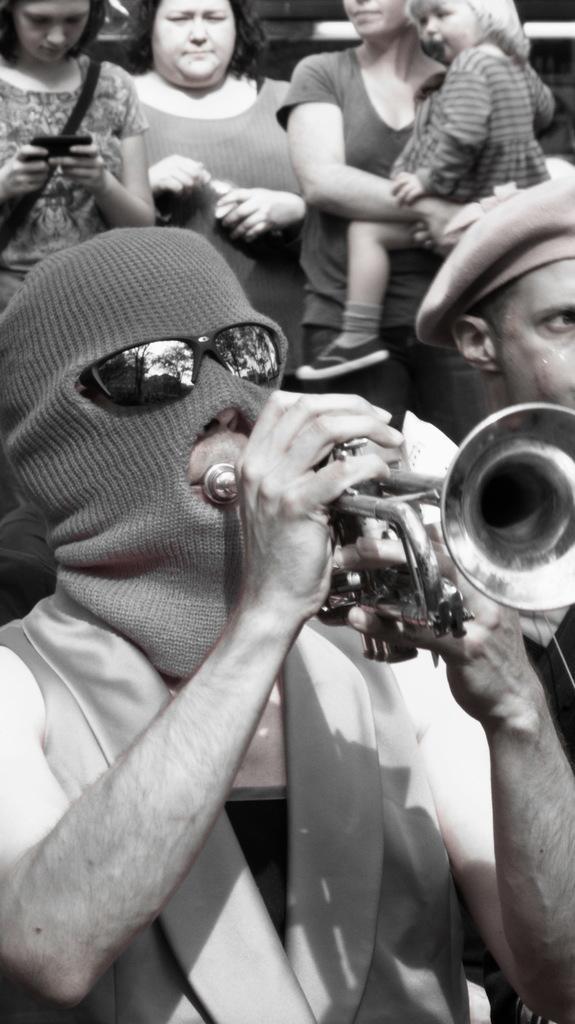In one or two sentences, can you explain what this image depicts? This picture is in black and white. The man in front of the picture wearing goggles is holding a trumpet in his hand. He is playing the trumpet. Behind him, we see people standing. On the left side, we see the woman who is wearing black bag is holding a mobile phone in her hands. 